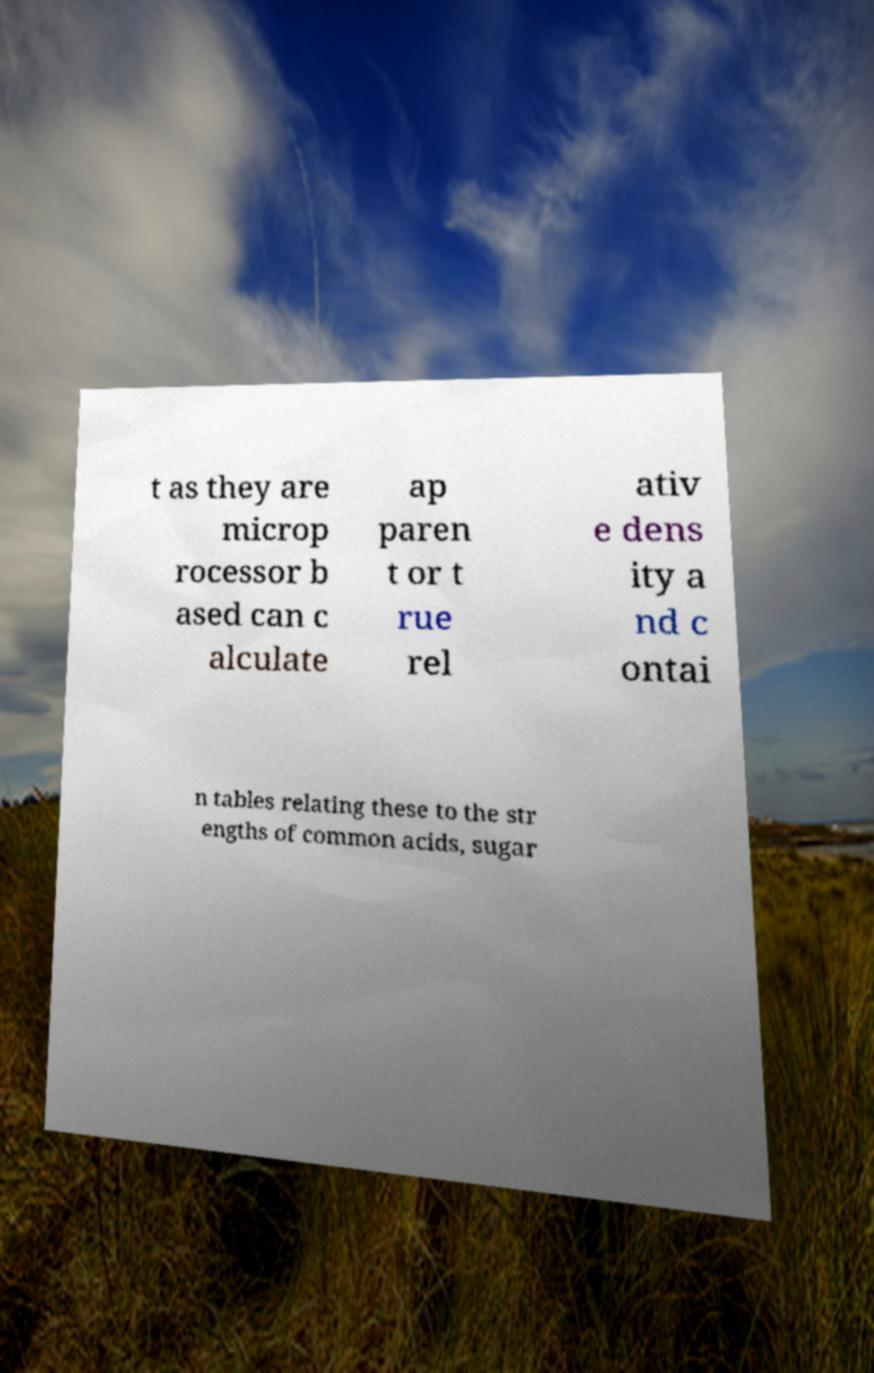Can you accurately transcribe the text from the provided image for me? t as they are microp rocessor b ased can c alculate ap paren t or t rue rel ativ e dens ity a nd c ontai n tables relating these to the str engths of common acids, sugar 